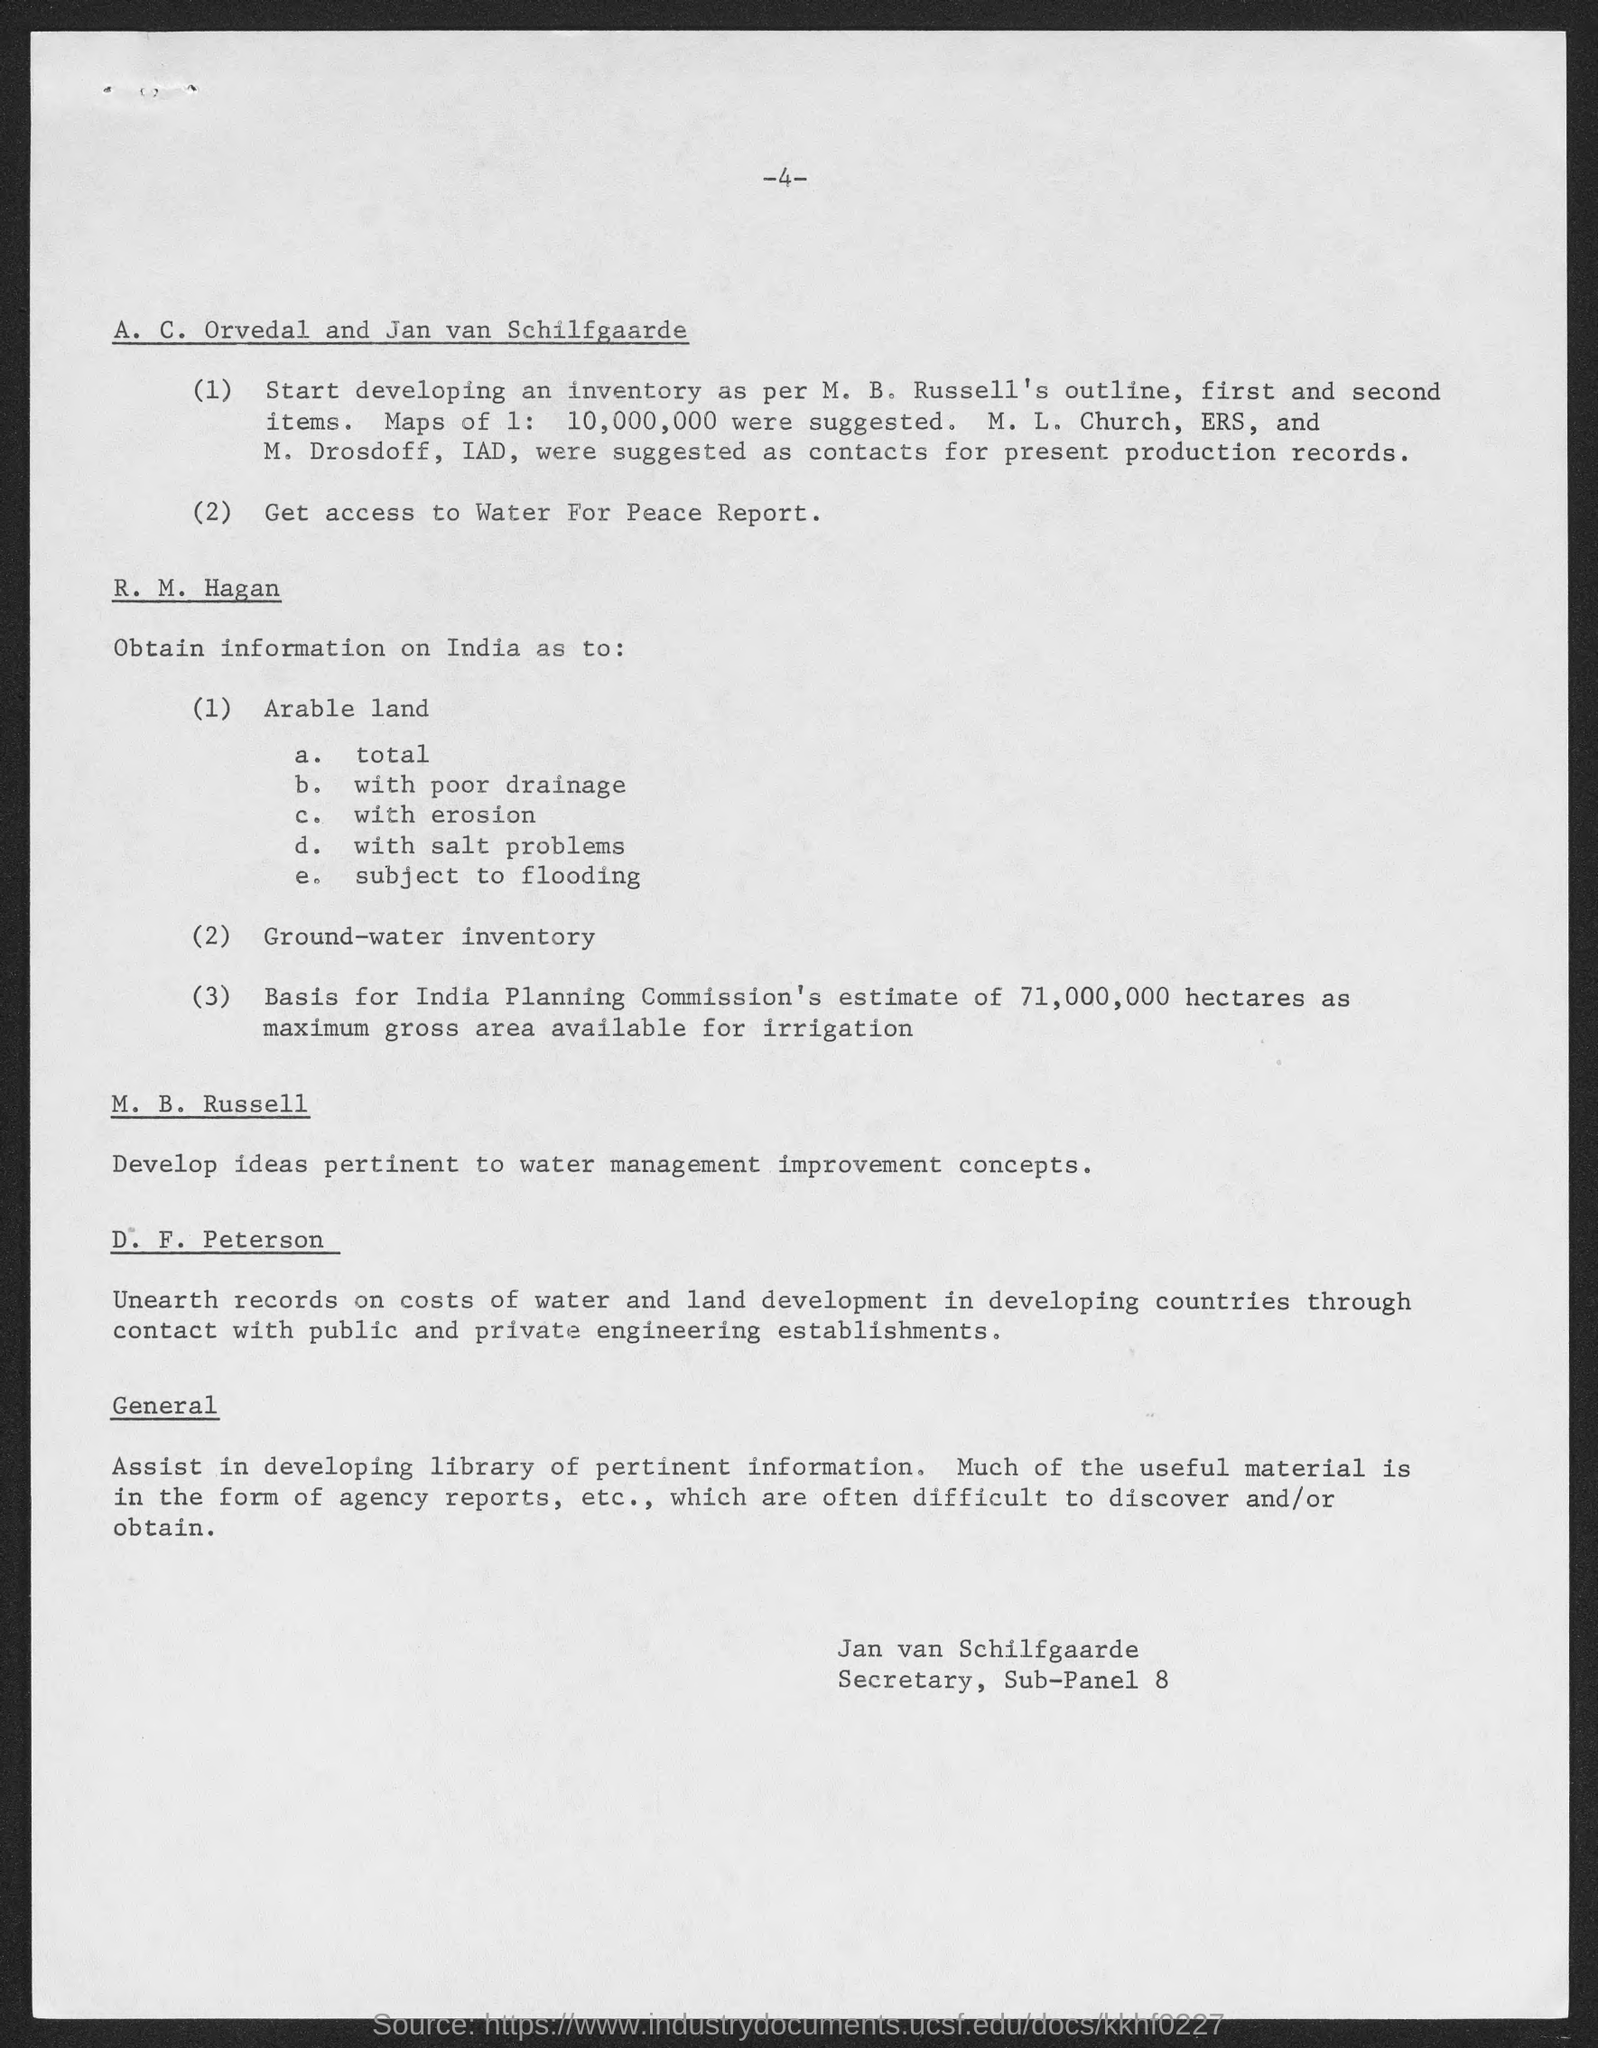Outline some significant characteristics in this image. M. B. Russell is in charge of the development of ideas pertinent to water management improvement concepts. Jan van Schilfgaarde is the secretary of Sub-panel 8. The maximum gross area available for irrigation in India is approximately 71,000,000 hectares, as indicated by the Planning Commission of India. 